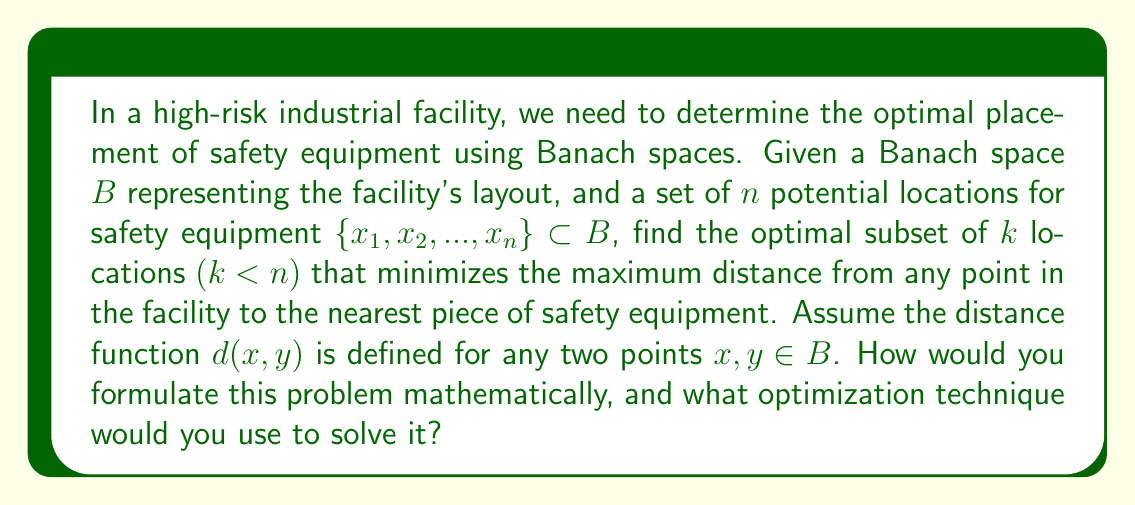What is the answer to this math problem? To solve this problem, we can formulate it as a min-max optimization problem in a Banach space. Here's a step-by-step approach:

1. Define the problem mathematically:
   Let $S \subset \{x_1, x_2, ..., x_n\}$ be a subset of $k$ locations.
   The objective function to minimize is:

   $$f(S) = \max_{y \in B} \min_{x \in S} d(x,y)$$

   This function represents the maximum distance from any point in the facility to the nearest piece of safety equipment.

2. Formulate the optimization problem:

   $$\min_{S \subset \{x_1, x_2, ..., x_n\}, |S|=k} f(S)$$

3. This problem is a combinatorial optimization problem in a Banach space, which is generally NP-hard. However, we can approach it using the following techniques:

   a) Greedy Algorithm: Start with an empty set and iteratively add the location that minimizes the maximum distance at each step until $k$ locations are selected.

   b) K-center clustering: This problem is equivalent to the k-center clustering problem in metric spaces. We can use approximation algorithms like Gonzalez's algorithm, which provides a 2-approximation.

   c) Mixed Integer Programming: Formulate the problem as a mixed integer program and solve it using branch-and-bound techniques.

4. For large-scale problems, we might need to use relaxation techniques or heuristic methods to find near-optimal solutions.

5. The solution will depend on the specific properties of the Banach space $B$ and the distance function $d(x,y)$. For example, if $B$ is a Hilbert space (a special case of Banach spaces), we can exploit its inner product structure for more efficient algorithms.

6. It's important to note that the optimal solution may not be unique, and there might be multiple configurations that achieve the same minimum maximum distance.

7. Once the optimal subset $S^*$ is found, we can calculate the optimal maximum distance as $f(S^*)$, which represents the worst-case distance to safety equipment in the facility.
Answer: The problem is formulated as:

$$\min_{S \subset \{x_1, x_2, ..., x_n\}, |S|=k} \max_{y \in B} \min_{x \in S} d(x,y)$$

This can be solved using k-center clustering algorithms or mixed integer programming techniques, depending on the specific properties of the Banach space and the scale of the problem. The solution will provide the optimal subset of $k$ locations for safety equipment placement that minimizes the maximum distance to safety equipment from any point in the facility. 